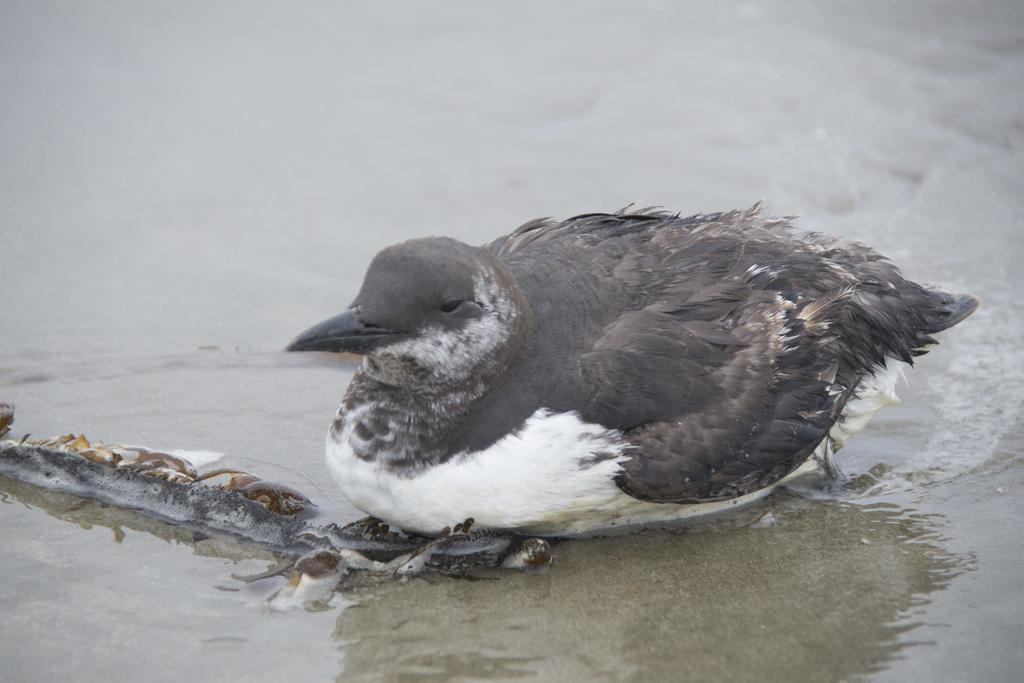What is the main subject in the center of the image? There is a bird in the center of the image. What can be seen on the left side of the image? There is an object on the left side of the image. What type of terrain is visible at the bottom of the image? There is sand at the bottom of the image. What is present on the right side of the image? There is water on the right side of the image. Can you tell me how many monkeys are interacting with the bird in the image? There are no monkeys present in the image; it features a bird, an object, sand, and water. What type of pipe is visible in the image? There is no pipe present in the image. 